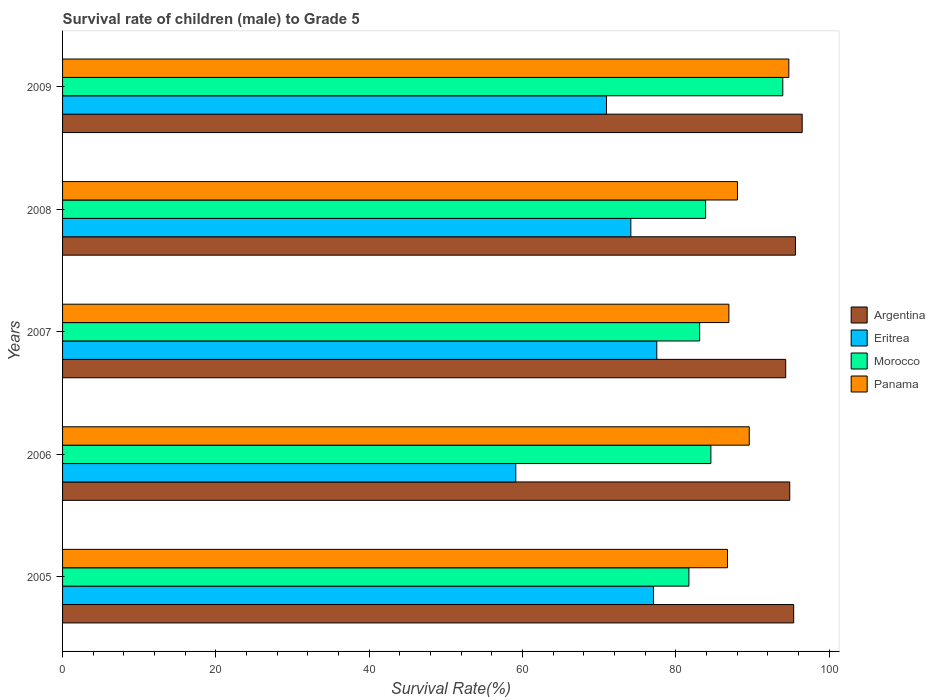How many different coloured bars are there?
Provide a short and direct response. 4. How many groups of bars are there?
Your answer should be very brief. 5. Are the number of bars on each tick of the Y-axis equal?
Offer a very short reply. Yes. How many bars are there on the 4th tick from the top?
Give a very brief answer. 4. In how many cases, is the number of bars for a given year not equal to the number of legend labels?
Make the answer very short. 0. What is the survival rate of male children to grade 5 in Morocco in 2009?
Ensure brevity in your answer.  93.95. Across all years, what is the maximum survival rate of male children to grade 5 in Argentina?
Your answer should be very brief. 96.48. Across all years, what is the minimum survival rate of male children to grade 5 in Panama?
Make the answer very short. 86.73. What is the total survival rate of male children to grade 5 in Argentina in the graph?
Provide a short and direct response. 476.62. What is the difference between the survival rate of male children to grade 5 in Panama in 2005 and that in 2008?
Provide a short and direct response. -1.3. What is the difference between the survival rate of male children to grade 5 in Argentina in 2008 and the survival rate of male children to grade 5 in Eritrea in 2007?
Give a very brief answer. 18.09. What is the average survival rate of male children to grade 5 in Eritrea per year?
Your answer should be very brief. 71.76. In the year 2009, what is the difference between the survival rate of male children to grade 5 in Eritrea and survival rate of male children to grade 5 in Morocco?
Offer a very short reply. -23. What is the ratio of the survival rate of male children to grade 5 in Argentina in 2007 to that in 2008?
Give a very brief answer. 0.99. Is the survival rate of male children to grade 5 in Eritrea in 2005 less than that in 2007?
Keep it short and to the point. Yes. Is the difference between the survival rate of male children to grade 5 in Eritrea in 2008 and 2009 greater than the difference between the survival rate of male children to grade 5 in Morocco in 2008 and 2009?
Offer a terse response. Yes. What is the difference between the highest and the second highest survival rate of male children to grade 5 in Eritrea?
Your answer should be compact. 0.43. What is the difference between the highest and the lowest survival rate of male children to grade 5 in Morocco?
Provide a short and direct response. 12.25. In how many years, is the survival rate of male children to grade 5 in Eritrea greater than the average survival rate of male children to grade 5 in Eritrea taken over all years?
Your response must be concise. 3. Is the sum of the survival rate of male children to grade 5 in Morocco in 2006 and 2007 greater than the maximum survival rate of male children to grade 5 in Eritrea across all years?
Make the answer very short. Yes. Is it the case that in every year, the sum of the survival rate of male children to grade 5 in Eritrea and survival rate of male children to grade 5 in Argentina is greater than the sum of survival rate of male children to grade 5 in Panama and survival rate of male children to grade 5 in Morocco?
Provide a short and direct response. No. What does the 4th bar from the top in 2005 represents?
Your answer should be very brief. Argentina. What does the 2nd bar from the bottom in 2006 represents?
Offer a terse response. Eritrea. How many bars are there?
Keep it short and to the point. 20. Are the values on the major ticks of X-axis written in scientific E-notation?
Your answer should be compact. No. Does the graph contain any zero values?
Offer a very short reply. No. Does the graph contain grids?
Provide a succinct answer. No. Where does the legend appear in the graph?
Keep it short and to the point. Center right. How are the legend labels stacked?
Your response must be concise. Vertical. What is the title of the graph?
Offer a terse response. Survival rate of children (male) to Grade 5. Does "San Marino" appear as one of the legend labels in the graph?
Offer a very short reply. No. What is the label or title of the X-axis?
Provide a succinct answer. Survival Rate(%). What is the Survival Rate(%) of Argentina in 2005?
Give a very brief answer. 95.37. What is the Survival Rate(%) of Eritrea in 2005?
Your answer should be compact. 77.08. What is the Survival Rate(%) in Morocco in 2005?
Ensure brevity in your answer.  81.7. What is the Survival Rate(%) in Panama in 2005?
Provide a succinct answer. 86.73. What is the Survival Rate(%) of Argentina in 2006?
Ensure brevity in your answer.  94.85. What is the Survival Rate(%) of Eritrea in 2006?
Ensure brevity in your answer.  59.12. What is the Survival Rate(%) of Morocco in 2006?
Offer a very short reply. 84.56. What is the Survival Rate(%) of Panama in 2006?
Your response must be concise. 89.57. What is the Survival Rate(%) in Argentina in 2007?
Give a very brief answer. 94.32. What is the Survival Rate(%) of Eritrea in 2007?
Your answer should be very brief. 77.51. What is the Survival Rate(%) of Morocco in 2007?
Your response must be concise. 83.1. What is the Survival Rate(%) of Panama in 2007?
Give a very brief answer. 86.91. What is the Survival Rate(%) of Argentina in 2008?
Make the answer very short. 95.6. What is the Survival Rate(%) in Eritrea in 2008?
Offer a terse response. 74.13. What is the Survival Rate(%) of Morocco in 2008?
Make the answer very short. 83.88. What is the Survival Rate(%) of Panama in 2008?
Offer a very short reply. 88.03. What is the Survival Rate(%) in Argentina in 2009?
Keep it short and to the point. 96.48. What is the Survival Rate(%) in Eritrea in 2009?
Make the answer very short. 70.95. What is the Survival Rate(%) in Morocco in 2009?
Provide a short and direct response. 93.95. What is the Survival Rate(%) of Panama in 2009?
Offer a very short reply. 94.73. Across all years, what is the maximum Survival Rate(%) of Argentina?
Offer a very short reply. 96.48. Across all years, what is the maximum Survival Rate(%) in Eritrea?
Ensure brevity in your answer.  77.51. Across all years, what is the maximum Survival Rate(%) in Morocco?
Your answer should be compact. 93.95. Across all years, what is the maximum Survival Rate(%) of Panama?
Provide a short and direct response. 94.73. Across all years, what is the minimum Survival Rate(%) of Argentina?
Ensure brevity in your answer.  94.32. Across all years, what is the minimum Survival Rate(%) in Eritrea?
Offer a very short reply. 59.12. Across all years, what is the minimum Survival Rate(%) in Morocco?
Keep it short and to the point. 81.7. Across all years, what is the minimum Survival Rate(%) in Panama?
Give a very brief answer. 86.73. What is the total Survival Rate(%) of Argentina in the graph?
Provide a succinct answer. 476.62. What is the total Survival Rate(%) in Eritrea in the graph?
Provide a short and direct response. 358.78. What is the total Survival Rate(%) in Morocco in the graph?
Give a very brief answer. 427.19. What is the total Survival Rate(%) in Panama in the graph?
Offer a terse response. 445.98. What is the difference between the Survival Rate(%) of Argentina in 2005 and that in 2006?
Provide a short and direct response. 0.51. What is the difference between the Survival Rate(%) of Eritrea in 2005 and that in 2006?
Provide a short and direct response. 17.96. What is the difference between the Survival Rate(%) in Morocco in 2005 and that in 2006?
Your answer should be compact. -2.87. What is the difference between the Survival Rate(%) of Panama in 2005 and that in 2006?
Your answer should be compact. -2.84. What is the difference between the Survival Rate(%) of Argentina in 2005 and that in 2007?
Give a very brief answer. 1.04. What is the difference between the Survival Rate(%) in Eritrea in 2005 and that in 2007?
Give a very brief answer. -0.43. What is the difference between the Survival Rate(%) of Morocco in 2005 and that in 2007?
Your answer should be very brief. -1.4. What is the difference between the Survival Rate(%) in Panama in 2005 and that in 2007?
Your answer should be compact. -0.18. What is the difference between the Survival Rate(%) in Argentina in 2005 and that in 2008?
Provide a short and direct response. -0.23. What is the difference between the Survival Rate(%) in Eritrea in 2005 and that in 2008?
Ensure brevity in your answer.  2.95. What is the difference between the Survival Rate(%) in Morocco in 2005 and that in 2008?
Offer a very short reply. -2.18. What is the difference between the Survival Rate(%) in Panama in 2005 and that in 2008?
Give a very brief answer. -1.3. What is the difference between the Survival Rate(%) of Argentina in 2005 and that in 2009?
Your answer should be very brief. -1.11. What is the difference between the Survival Rate(%) in Eritrea in 2005 and that in 2009?
Your response must be concise. 6.13. What is the difference between the Survival Rate(%) of Morocco in 2005 and that in 2009?
Offer a very short reply. -12.25. What is the difference between the Survival Rate(%) in Panama in 2005 and that in 2009?
Provide a succinct answer. -8. What is the difference between the Survival Rate(%) in Argentina in 2006 and that in 2007?
Offer a terse response. 0.53. What is the difference between the Survival Rate(%) of Eritrea in 2006 and that in 2007?
Your answer should be compact. -18.39. What is the difference between the Survival Rate(%) of Morocco in 2006 and that in 2007?
Give a very brief answer. 1.46. What is the difference between the Survival Rate(%) in Panama in 2006 and that in 2007?
Your answer should be very brief. 2.66. What is the difference between the Survival Rate(%) in Argentina in 2006 and that in 2008?
Your response must be concise. -0.75. What is the difference between the Survival Rate(%) of Eritrea in 2006 and that in 2008?
Make the answer very short. -15.01. What is the difference between the Survival Rate(%) of Morocco in 2006 and that in 2008?
Your response must be concise. 0.69. What is the difference between the Survival Rate(%) of Panama in 2006 and that in 2008?
Offer a very short reply. 1.54. What is the difference between the Survival Rate(%) of Argentina in 2006 and that in 2009?
Provide a succinct answer. -1.62. What is the difference between the Survival Rate(%) in Eritrea in 2006 and that in 2009?
Give a very brief answer. -11.83. What is the difference between the Survival Rate(%) in Morocco in 2006 and that in 2009?
Make the answer very short. -9.38. What is the difference between the Survival Rate(%) of Panama in 2006 and that in 2009?
Provide a short and direct response. -5.16. What is the difference between the Survival Rate(%) of Argentina in 2007 and that in 2008?
Offer a terse response. -1.28. What is the difference between the Survival Rate(%) of Eritrea in 2007 and that in 2008?
Make the answer very short. 3.38. What is the difference between the Survival Rate(%) of Morocco in 2007 and that in 2008?
Your response must be concise. -0.77. What is the difference between the Survival Rate(%) of Panama in 2007 and that in 2008?
Keep it short and to the point. -1.12. What is the difference between the Survival Rate(%) in Argentina in 2007 and that in 2009?
Offer a terse response. -2.15. What is the difference between the Survival Rate(%) in Eritrea in 2007 and that in 2009?
Keep it short and to the point. 6.56. What is the difference between the Survival Rate(%) in Morocco in 2007 and that in 2009?
Provide a short and direct response. -10.84. What is the difference between the Survival Rate(%) in Panama in 2007 and that in 2009?
Your answer should be compact. -7.82. What is the difference between the Survival Rate(%) of Argentina in 2008 and that in 2009?
Offer a terse response. -0.88. What is the difference between the Survival Rate(%) in Eritrea in 2008 and that in 2009?
Your answer should be compact. 3.18. What is the difference between the Survival Rate(%) of Morocco in 2008 and that in 2009?
Provide a short and direct response. -10.07. What is the difference between the Survival Rate(%) of Panama in 2008 and that in 2009?
Your answer should be compact. -6.7. What is the difference between the Survival Rate(%) in Argentina in 2005 and the Survival Rate(%) in Eritrea in 2006?
Keep it short and to the point. 36.25. What is the difference between the Survival Rate(%) in Argentina in 2005 and the Survival Rate(%) in Morocco in 2006?
Your answer should be compact. 10.8. What is the difference between the Survival Rate(%) of Argentina in 2005 and the Survival Rate(%) of Panama in 2006?
Provide a succinct answer. 5.8. What is the difference between the Survival Rate(%) in Eritrea in 2005 and the Survival Rate(%) in Morocco in 2006?
Ensure brevity in your answer.  -7.49. What is the difference between the Survival Rate(%) in Eritrea in 2005 and the Survival Rate(%) in Panama in 2006?
Ensure brevity in your answer.  -12.5. What is the difference between the Survival Rate(%) of Morocco in 2005 and the Survival Rate(%) of Panama in 2006?
Your answer should be very brief. -7.87. What is the difference between the Survival Rate(%) of Argentina in 2005 and the Survival Rate(%) of Eritrea in 2007?
Your response must be concise. 17.86. What is the difference between the Survival Rate(%) of Argentina in 2005 and the Survival Rate(%) of Morocco in 2007?
Provide a succinct answer. 12.26. What is the difference between the Survival Rate(%) in Argentina in 2005 and the Survival Rate(%) in Panama in 2007?
Your response must be concise. 8.45. What is the difference between the Survival Rate(%) in Eritrea in 2005 and the Survival Rate(%) in Morocco in 2007?
Give a very brief answer. -6.03. What is the difference between the Survival Rate(%) of Eritrea in 2005 and the Survival Rate(%) of Panama in 2007?
Your answer should be very brief. -9.84. What is the difference between the Survival Rate(%) of Morocco in 2005 and the Survival Rate(%) of Panama in 2007?
Ensure brevity in your answer.  -5.22. What is the difference between the Survival Rate(%) of Argentina in 2005 and the Survival Rate(%) of Eritrea in 2008?
Make the answer very short. 21.24. What is the difference between the Survival Rate(%) of Argentina in 2005 and the Survival Rate(%) of Morocco in 2008?
Make the answer very short. 11.49. What is the difference between the Survival Rate(%) in Argentina in 2005 and the Survival Rate(%) in Panama in 2008?
Make the answer very short. 7.33. What is the difference between the Survival Rate(%) of Eritrea in 2005 and the Survival Rate(%) of Morocco in 2008?
Your response must be concise. -6.8. What is the difference between the Survival Rate(%) of Eritrea in 2005 and the Survival Rate(%) of Panama in 2008?
Keep it short and to the point. -10.96. What is the difference between the Survival Rate(%) in Morocco in 2005 and the Survival Rate(%) in Panama in 2008?
Your answer should be compact. -6.33. What is the difference between the Survival Rate(%) in Argentina in 2005 and the Survival Rate(%) in Eritrea in 2009?
Give a very brief answer. 24.42. What is the difference between the Survival Rate(%) in Argentina in 2005 and the Survival Rate(%) in Morocco in 2009?
Give a very brief answer. 1.42. What is the difference between the Survival Rate(%) in Argentina in 2005 and the Survival Rate(%) in Panama in 2009?
Offer a terse response. 0.63. What is the difference between the Survival Rate(%) in Eritrea in 2005 and the Survival Rate(%) in Morocco in 2009?
Provide a short and direct response. -16.87. What is the difference between the Survival Rate(%) of Eritrea in 2005 and the Survival Rate(%) of Panama in 2009?
Offer a terse response. -17.66. What is the difference between the Survival Rate(%) of Morocco in 2005 and the Survival Rate(%) of Panama in 2009?
Offer a very short reply. -13.03. What is the difference between the Survival Rate(%) of Argentina in 2006 and the Survival Rate(%) of Eritrea in 2007?
Your answer should be very brief. 17.34. What is the difference between the Survival Rate(%) of Argentina in 2006 and the Survival Rate(%) of Morocco in 2007?
Your answer should be compact. 11.75. What is the difference between the Survival Rate(%) in Argentina in 2006 and the Survival Rate(%) in Panama in 2007?
Make the answer very short. 7.94. What is the difference between the Survival Rate(%) of Eritrea in 2006 and the Survival Rate(%) of Morocco in 2007?
Your answer should be very brief. -23.98. What is the difference between the Survival Rate(%) of Eritrea in 2006 and the Survival Rate(%) of Panama in 2007?
Give a very brief answer. -27.8. What is the difference between the Survival Rate(%) in Morocco in 2006 and the Survival Rate(%) in Panama in 2007?
Keep it short and to the point. -2.35. What is the difference between the Survival Rate(%) of Argentina in 2006 and the Survival Rate(%) of Eritrea in 2008?
Your answer should be compact. 20.73. What is the difference between the Survival Rate(%) of Argentina in 2006 and the Survival Rate(%) of Morocco in 2008?
Your answer should be compact. 10.98. What is the difference between the Survival Rate(%) in Argentina in 2006 and the Survival Rate(%) in Panama in 2008?
Your answer should be very brief. 6.82. What is the difference between the Survival Rate(%) of Eritrea in 2006 and the Survival Rate(%) of Morocco in 2008?
Make the answer very short. -24.76. What is the difference between the Survival Rate(%) of Eritrea in 2006 and the Survival Rate(%) of Panama in 2008?
Provide a succinct answer. -28.91. What is the difference between the Survival Rate(%) of Morocco in 2006 and the Survival Rate(%) of Panama in 2008?
Your answer should be compact. -3.47. What is the difference between the Survival Rate(%) of Argentina in 2006 and the Survival Rate(%) of Eritrea in 2009?
Provide a short and direct response. 23.91. What is the difference between the Survival Rate(%) in Argentina in 2006 and the Survival Rate(%) in Morocco in 2009?
Ensure brevity in your answer.  0.91. What is the difference between the Survival Rate(%) in Argentina in 2006 and the Survival Rate(%) in Panama in 2009?
Your answer should be very brief. 0.12. What is the difference between the Survival Rate(%) of Eritrea in 2006 and the Survival Rate(%) of Morocco in 2009?
Keep it short and to the point. -34.83. What is the difference between the Survival Rate(%) in Eritrea in 2006 and the Survival Rate(%) in Panama in 2009?
Provide a succinct answer. -35.61. What is the difference between the Survival Rate(%) in Morocco in 2006 and the Survival Rate(%) in Panama in 2009?
Offer a very short reply. -10.17. What is the difference between the Survival Rate(%) in Argentina in 2007 and the Survival Rate(%) in Eritrea in 2008?
Keep it short and to the point. 20.2. What is the difference between the Survival Rate(%) of Argentina in 2007 and the Survival Rate(%) of Morocco in 2008?
Provide a short and direct response. 10.45. What is the difference between the Survival Rate(%) of Argentina in 2007 and the Survival Rate(%) of Panama in 2008?
Keep it short and to the point. 6.29. What is the difference between the Survival Rate(%) in Eritrea in 2007 and the Survival Rate(%) in Morocco in 2008?
Provide a succinct answer. -6.37. What is the difference between the Survival Rate(%) in Eritrea in 2007 and the Survival Rate(%) in Panama in 2008?
Ensure brevity in your answer.  -10.52. What is the difference between the Survival Rate(%) in Morocco in 2007 and the Survival Rate(%) in Panama in 2008?
Your response must be concise. -4.93. What is the difference between the Survival Rate(%) of Argentina in 2007 and the Survival Rate(%) of Eritrea in 2009?
Provide a succinct answer. 23.38. What is the difference between the Survival Rate(%) of Argentina in 2007 and the Survival Rate(%) of Morocco in 2009?
Keep it short and to the point. 0.38. What is the difference between the Survival Rate(%) in Argentina in 2007 and the Survival Rate(%) in Panama in 2009?
Your response must be concise. -0.41. What is the difference between the Survival Rate(%) in Eritrea in 2007 and the Survival Rate(%) in Morocco in 2009?
Offer a terse response. -16.44. What is the difference between the Survival Rate(%) of Eritrea in 2007 and the Survival Rate(%) of Panama in 2009?
Your answer should be compact. -17.22. What is the difference between the Survival Rate(%) of Morocco in 2007 and the Survival Rate(%) of Panama in 2009?
Ensure brevity in your answer.  -11.63. What is the difference between the Survival Rate(%) in Argentina in 2008 and the Survival Rate(%) in Eritrea in 2009?
Keep it short and to the point. 24.65. What is the difference between the Survival Rate(%) of Argentina in 2008 and the Survival Rate(%) of Morocco in 2009?
Make the answer very short. 1.65. What is the difference between the Survival Rate(%) of Argentina in 2008 and the Survival Rate(%) of Panama in 2009?
Offer a very short reply. 0.87. What is the difference between the Survival Rate(%) in Eritrea in 2008 and the Survival Rate(%) in Morocco in 2009?
Ensure brevity in your answer.  -19.82. What is the difference between the Survival Rate(%) of Eritrea in 2008 and the Survival Rate(%) of Panama in 2009?
Give a very brief answer. -20.61. What is the difference between the Survival Rate(%) of Morocco in 2008 and the Survival Rate(%) of Panama in 2009?
Provide a succinct answer. -10.86. What is the average Survival Rate(%) of Argentina per year?
Provide a short and direct response. 95.32. What is the average Survival Rate(%) of Eritrea per year?
Keep it short and to the point. 71.76. What is the average Survival Rate(%) of Morocco per year?
Your answer should be compact. 85.44. What is the average Survival Rate(%) in Panama per year?
Give a very brief answer. 89.2. In the year 2005, what is the difference between the Survival Rate(%) of Argentina and Survival Rate(%) of Eritrea?
Give a very brief answer. 18.29. In the year 2005, what is the difference between the Survival Rate(%) of Argentina and Survival Rate(%) of Morocco?
Offer a terse response. 13.67. In the year 2005, what is the difference between the Survival Rate(%) in Argentina and Survival Rate(%) in Panama?
Your answer should be compact. 8.64. In the year 2005, what is the difference between the Survival Rate(%) in Eritrea and Survival Rate(%) in Morocco?
Provide a succinct answer. -4.62. In the year 2005, what is the difference between the Survival Rate(%) of Eritrea and Survival Rate(%) of Panama?
Ensure brevity in your answer.  -9.66. In the year 2005, what is the difference between the Survival Rate(%) of Morocco and Survival Rate(%) of Panama?
Offer a very short reply. -5.03. In the year 2006, what is the difference between the Survival Rate(%) of Argentina and Survival Rate(%) of Eritrea?
Offer a terse response. 35.73. In the year 2006, what is the difference between the Survival Rate(%) of Argentina and Survival Rate(%) of Morocco?
Your answer should be very brief. 10.29. In the year 2006, what is the difference between the Survival Rate(%) of Argentina and Survival Rate(%) of Panama?
Your response must be concise. 5.28. In the year 2006, what is the difference between the Survival Rate(%) in Eritrea and Survival Rate(%) in Morocco?
Give a very brief answer. -25.45. In the year 2006, what is the difference between the Survival Rate(%) of Eritrea and Survival Rate(%) of Panama?
Keep it short and to the point. -30.45. In the year 2006, what is the difference between the Survival Rate(%) of Morocco and Survival Rate(%) of Panama?
Your answer should be very brief. -5.01. In the year 2007, what is the difference between the Survival Rate(%) of Argentina and Survival Rate(%) of Eritrea?
Your answer should be very brief. 16.81. In the year 2007, what is the difference between the Survival Rate(%) of Argentina and Survival Rate(%) of Morocco?
Offer a terse response. 11.22. In the year 2007, what is the difference between the Survival Rate(%) of Argentina and Survival Rate(%) of Panama?
Ensure brevity in your answer.  7.41. In the year 2007, what is the difference between the Survival Rate(%) in Eritrea and Survival Rate(%) in Morocco?
Your response must be concise. -5.59. In the year 2007, what is the difference between the Survival Rate(%) in Eritrea and Survival Rate(%) in Panama?
Offer a terse response. -9.4. In the year 2007, what is the difference between the Survival Rate(%) in Morocco and Survival Rate(%) in Panama?
Provide a succinct answer. -3.81. In the year 2008, what is the difference between the Survival Rate(%) in Argentina and Survival Rate(%) in Eritrea?
Provide a succinct answer. 21.47. In the year 2008, what is the difference between the Survival Rate(%) of Argentina and Survival Rate(%) of Morocco?
Your response must be concise. 11.72. In the year 2008, what is the difference between the Survival Rate(%) in Argentina and Survival Rate(%) in Panama?
Your response must be concise. 7.57. In the year 2008, what is the difference between the Survival Rate(%) in Eritrea and Survival Rate(%) in Morocco?
Give a very brief answer. -9.75. In the year 2008, what is the difference between the Survival Rate(%) of Eritrea and Survival Rate(%) of Panama?
Offer a very short reply. -13.91. In the year 2008, what is the difference between the Survival Rate(%) in Morocco and Survival Rate(%) in Panama?
Your answer should be compact. -4.15. In the year 2009, what is the difference between the Survival Rate(%) in Argentina and Survival Rate(%) in Eritrea?
Your answer should be very brief. 25.53. In the year 2009, what is the difference between the Survival Rate(%) of Argentina and Survival Rate(%) of Morocco?
Give a very brief answer. 2.53. In the year 2009, what is the difference between the Survival Rate(%) in Argentina and Survival Rate(%) in Panama?
Offer a terse response. 1.74. In the year 2009, what is the difference between the Survival Rate(%) in Eritrea and Survival Rate(%) in Morocco?
Keep it short and to the point. -23. In the year 2009, what is the difference between the Survival Rate(%) in Eritrea and Survival Rate(%) in Panama?
Your answer should be very brief. -23.79. In the year 2009, what is the difference between the Survival Rate(%) in Morocco and Survival Rate(%) in Panama?
Give a very brief answer. -0.79. What is the ratio of the Survival Rate(%) in Argentina in 2005 to that in 2006?
Your answer should be very brief. 1.01. What is the ratio of the Survival Rate(%) of Eritrea in 2005 to that in 2006?
Give a very brief answer. 1.3. What is the ratio of the Survival Rate(%) in Morocco in 2005 to that in 2006?
Give a very brief answer. 0.97. What is the ratio of the Survival Rate(%) of Panama in 2005 to that in 2006?
Offer a very short reply. 0.97. What is the ratio of the Survival Rate(%) of Eritrea in 2005 to that in 2007?
Make the answer very short. 0.99. What is the ratio of the Survival Rate(%) in Morocco in 2005 to that in 2007?
Provide a succinct answer. 0.98. What is the ratio of the Survival Rate(%) in Panama in 2005 to that in 2007?
Keep it short and to the point. 1. What is the ratio of the Survival Rate(%) in Eritrea in 2005 to that in 2008?
Offer a very short reply. 1.04. What is the ratio of the Survival Rate(%) in Panama in 2005 to that in 2008?
Ensure brevity in your answer.  0.99. What is the ratio of the Survival Rate(%) in Argentina in 2005 to that in 2009?
Offer a terse response. 0.99. What is the ratio of the Survival Rate(%) of Eritrea in 2005 to that in 2009?
Your answer should be compact. 1.09. What is the ratio of the Survival Rate(%) in Morocco in 2005 to that in 2009?
Your response must be concise. 0.87. What is the ratio of the Survival Rate(%) in Panama in 2005 to that in 2009?
Provide a short and direct response. 0.92. What is the ratio of the Survival Rate(%) of Argentina in 2006 to that in 2007?
Provide a succinct answer. 1.01. What is the ratio of the Survival Rate(%) of Eritrea in 2006 to that in 2007?
Offer a very short reply. 0.76. What is the ratio of the Survival Rate(%) in Morocco in 2006 to that in 2007?
Offer a terse response. 1.02. What is the ratio of the Survival Rate(%) of Panama in 2006 to that in 2007?
Ensure brevity in your answer.  1.03. What is the ratio of the Survival Rate(%) in Eritrea in 2006 to that in 2008?
Your answer should be very brief. 0.8. What is the ratio of the Survival Rate(%) of Morocco in 2006 to that in 2008?
Give a very brief answer. 1.01. What is the ratio of the Survival Rate(%) in Panama in 2006 to that in 2008?
Provide a succinct answer. 1.02. What is the ratio of the Survival Rate(%) in Argentina in 2006 to that in 2009?
Provide a succinct answer. 0.98. What is the ratio of the Survival Rate(%) in Morocco in 2006 to that in 2009?
Your answer should be compact. 0.9. What is the ratio of the Survival Rate(%) in Panama in 2006 to that in 2009?
Give a very brief answer. 0.95. What is the ratio of the Survival Rate(%) in Argentina in 2007 to that in 2008?
Offer a very short reply. 0.99. What is the ratio of the Survival Rate(%) in Eritrea in 2007 to that in 2008?
Your answer should be very brief. 1.05. What is the ratio of the Survival Rate(%) in Morocco in 2007 to that in 2008?
Your response must be concise. 0.99. What is the ratio of the Survival Rate(%) of Panama in 2007 to that in 2008?
Your answer should be compact. 0.99. What is the ratio of the Survival Rate(%) of Argentina in 2007 to that in 2009?
Provide a succinct answer. 0.98. What is the ratio of the Survival Rate(%) of Eritrea in 2007 to that in 2009?
Offer a terse response. 1.09. What is the ratio of the Survival Rate(%) in Morocco in 2007 to that in 2009?
Offer a very short reply. 0.88. What is the ratio of the Survival Rate(%) in Panama in 2007 to that in 2009?
Provide a short and direct response. 0.92. What is the ratio of the Survival Rate(%) in Argentina in 2008 to that in 2009?
Provide a succinct answer. 0.99. What is the ratio of the Survival Rate(%) in Eritrea in 2008 to that in 2009?
Give a very brief answer. 1.04. What is the ratio of the Survival Rate(%) in Morocco in 2008 to that in 2009?
Your answer should be compact. 0.89. What is the ratio of the Survival Rate(%) in Panama in 2008 to that in 2009?
Your answer should be very brief. 0.93. What is the difference between the highest and the second highest Survival Rate(%) in Argentina?
Make the answer very short. 0.88. What is the difference between the highest and the second highest Survival Rate(%) of Eritrea?
Your answer should be very brief. 0.43. What is the difference between the highest and the second highest Survival Rate(%) in Morocco?
Give a very brief answer. 9.38. What is the difference between the highest and the second highest Survival Rate(%) in Panama?
Ensure brevity in your answer.  5.16. What is the difference between the highest and the lowest Survival Rate(%) in Argentina?
Offer a terse response. 2.15. What is the difference between the highest and the lowest Survival Rate(%) in Eritrea?
Make the answer very short. 18.39. What is the difference between the highest and the lowest Survival Rate(%) in Morocco?
Your response must be concise. 12.25. What is the difference between the highest and the lowest Survival Rate(%) of Panama?
Offer a very short reply. 8. 